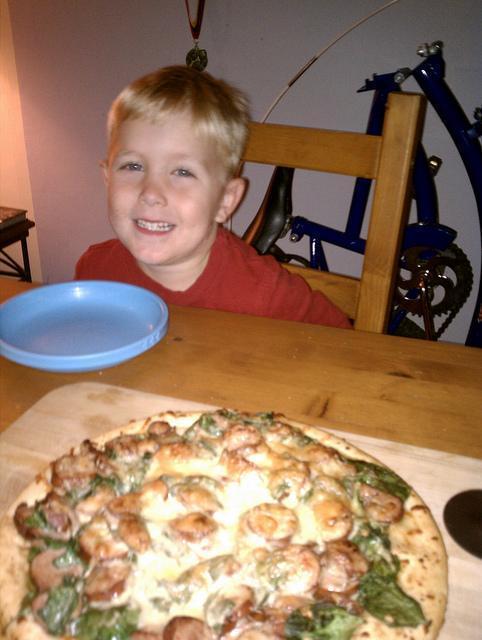Is the given caption "The bicycle is below the pizza." fitting for the image?
Answer yes or no. No. Is the caption "The pizza is attached to the bicycle." a true representation of the image?
Answer yes or no. No. Is "The pizza is above the bicycle." an appropriate description for the image?
Answer yes or no. No. Evaluate: Does the caption "The pizza is connected to the bicycle." match the image?
Answer yes or no. No. Is this affirmation: "The bicycle is off the pizza." correct?
Answer yes or no. Yes. Verify the accuracy of this image caption: "The person is behind the pizza.".
Answer yes or no. Yes. 